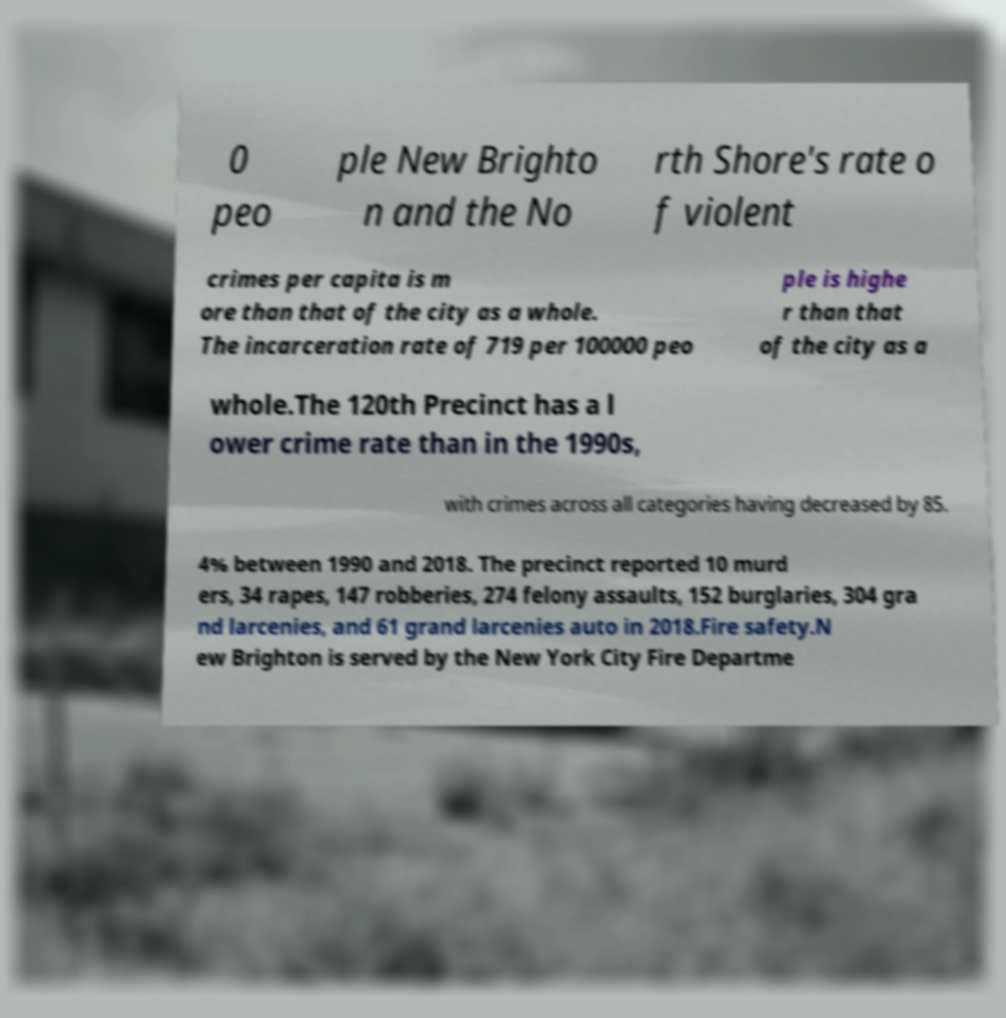Could you assist in decoding the text presented in this image and type it out clearly? 0 peo ple New Brighto n and the No rth Shore's rate o f violent crimes per capita is m ore than that of the city as a whole. The incarceration rate of 719 per 100000 peo ple is highe r than that of the city as a whole.The 120th Precinct has a l ower crime rate than in the 1990s, with crimes across all categories having decreased by 85. 4% between 1990 and 2018. The precinct reported 10 murd ers, 34 rapes, 147 robberies, 274 felony assaults, 152 burglaries, 304 gra nd larcenies, and 61 grand larcenies auto in 2018.Fire safety.N ew Brighton is served by the New York City Fire Departme 